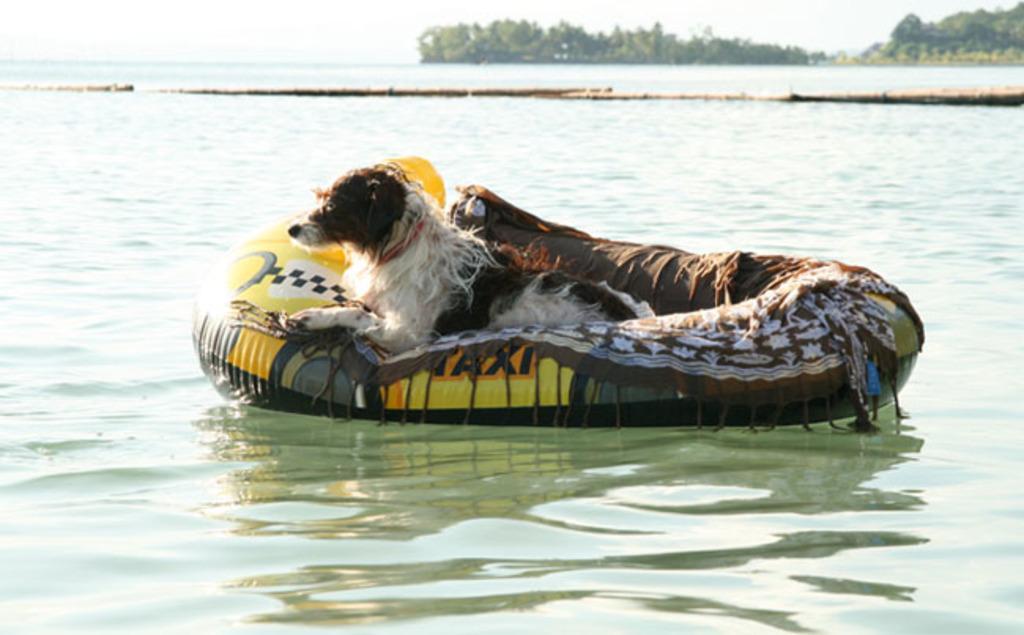Can you describe this image briefly? In this picture I see the water and I see a tube in front on which there is a dog which is of white and brown in color. In the background I see the trees and the sky. 